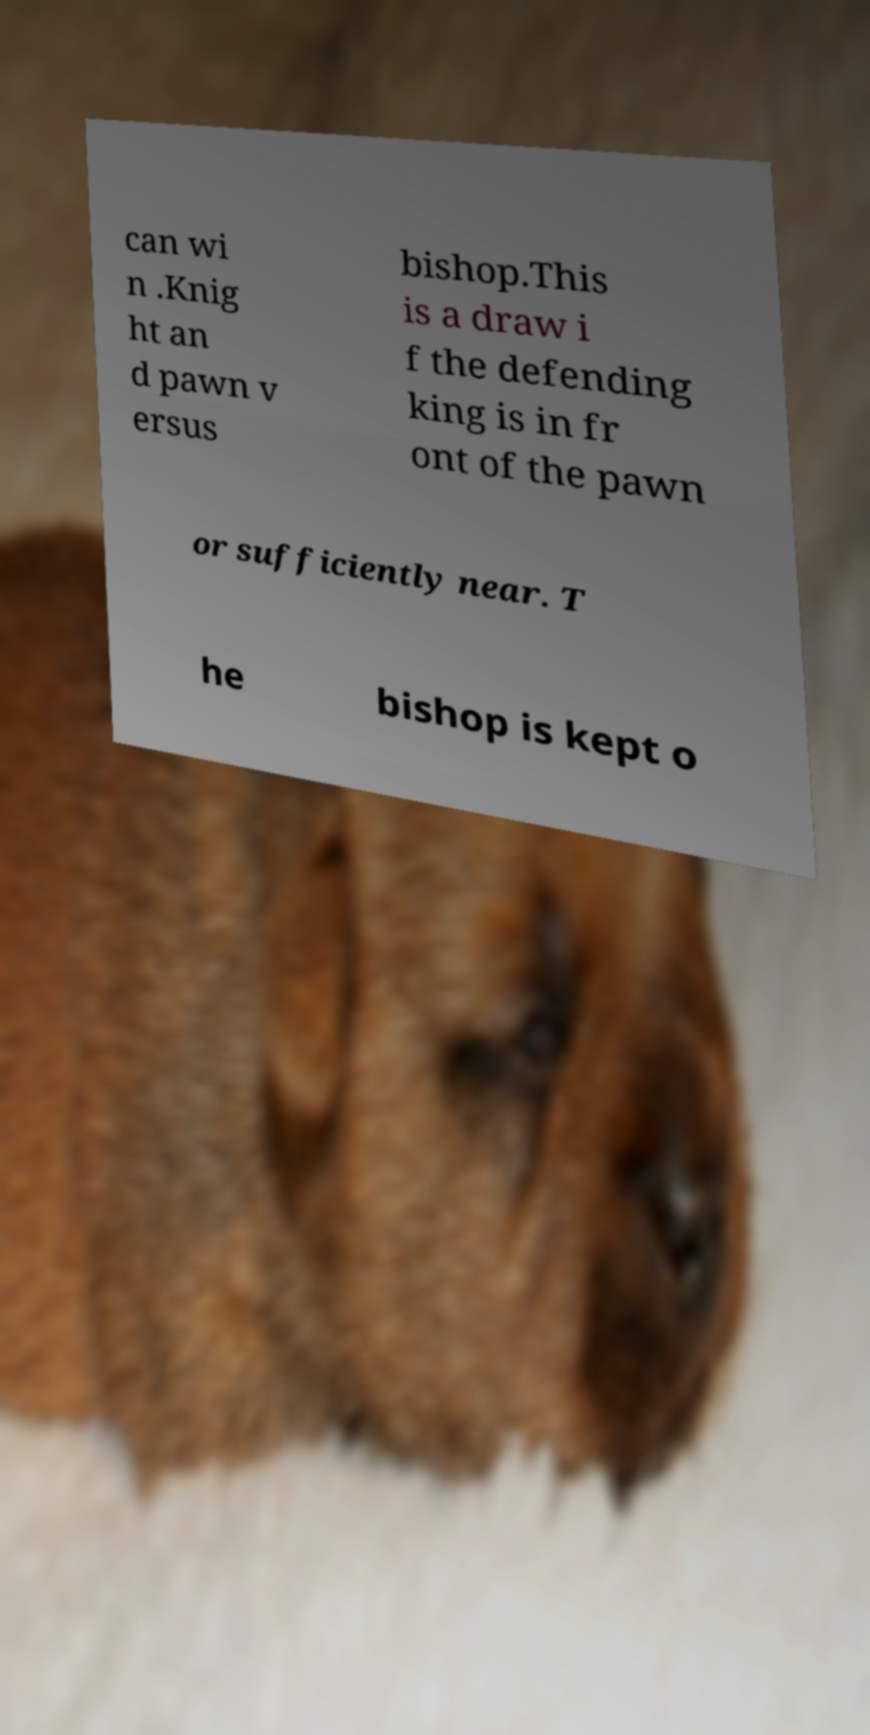For documentation purposes, I need the text within this image transcribed. Could you provide that? can wi n .Knig ht an d pawn v ersus bishop.This is a draw i f the defending king is in fr ont of the pawn or sufficiently near. T he bishop is kept o 